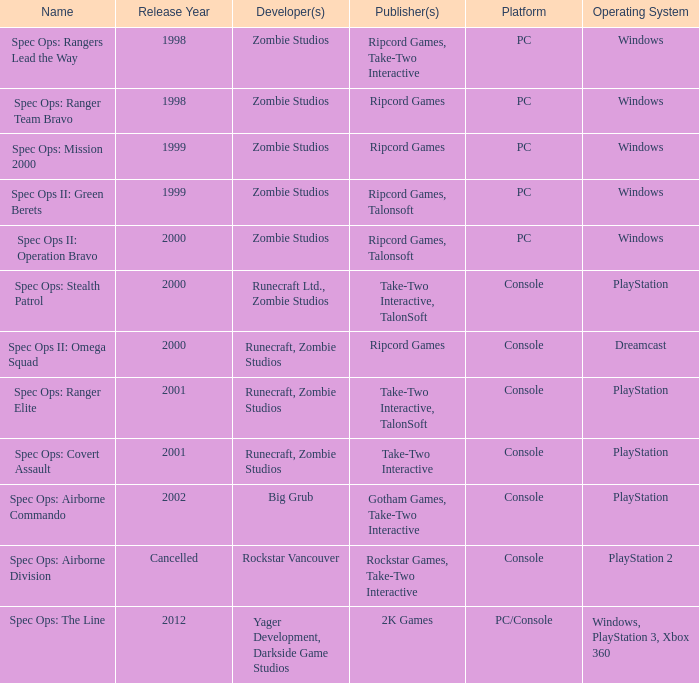Which developer has a year of cancelled releases? Rockstar Vancouver. 